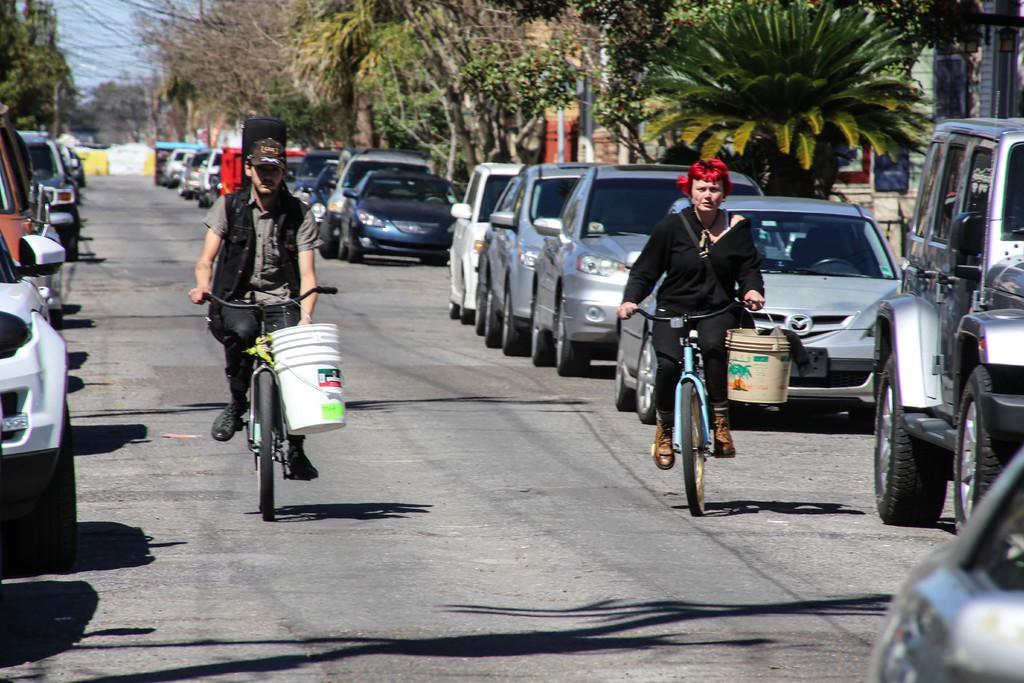Could you give a brief overview of what you see in this image? In this image two people are riding bicycle on the road and we can find couple of cars, buildings and trees. 